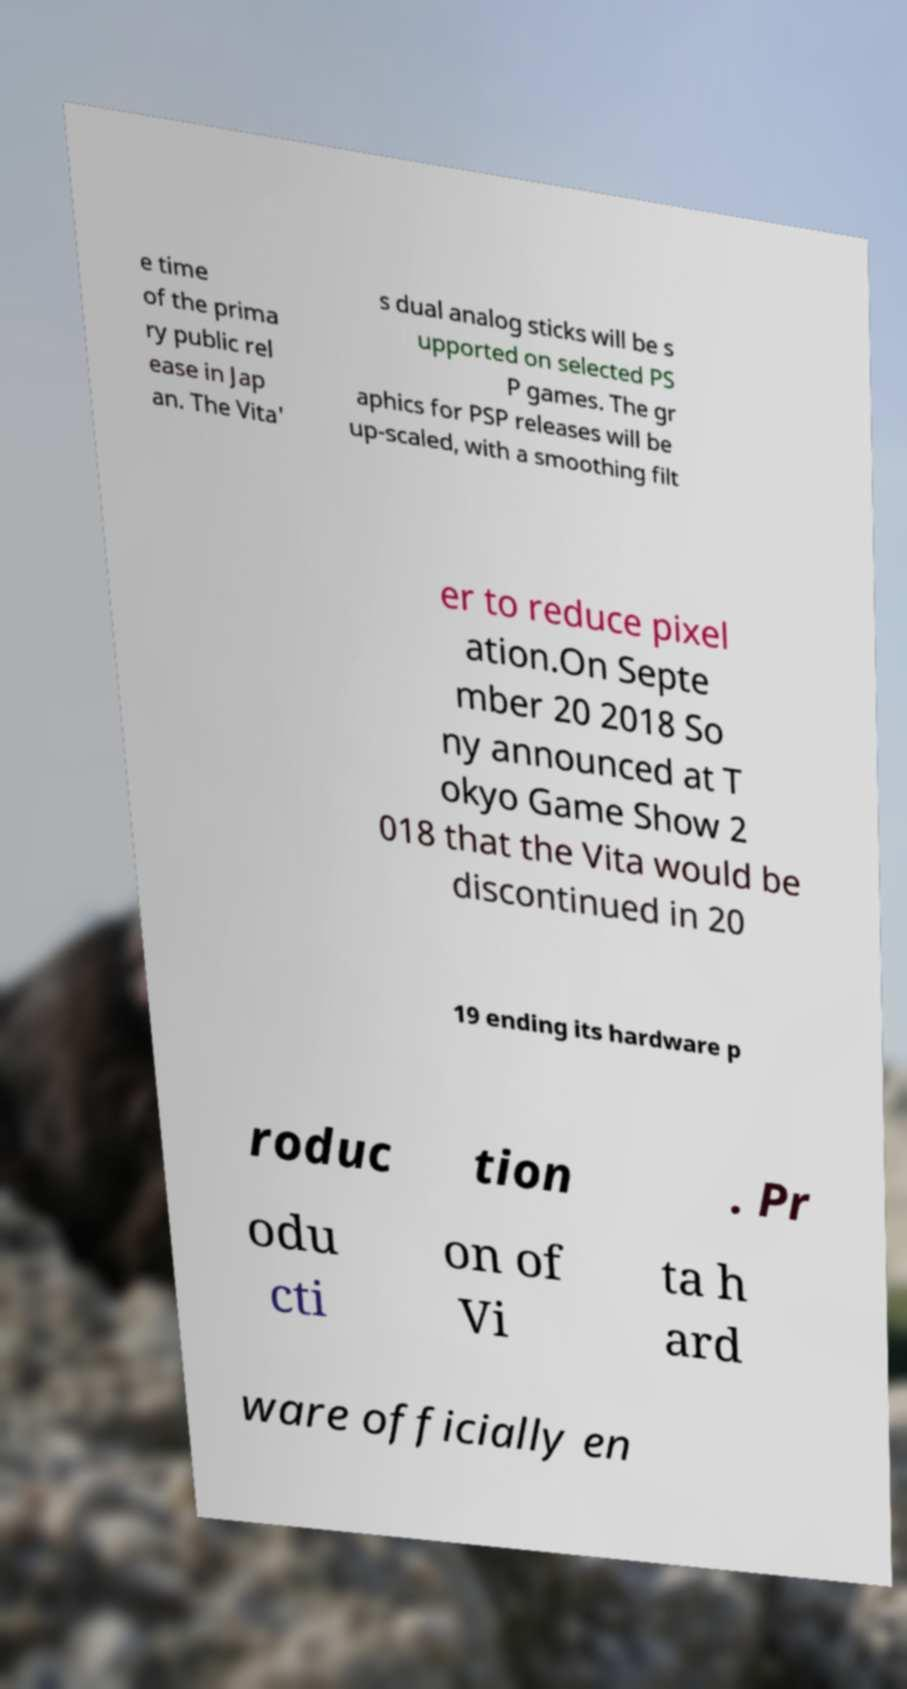Can you accurately transcribe the text from the provided image for me? e time of the prima ry public rel ease in Jap an. The Vita' s dual analog sticks will be s upported on selected PS P games. The gr aphics for PSP releases will be up-scaled, with a smoothing filt er to reduce pixel ation.On Septe mber 20 2018 So ny announced at T okyo Game Show 2 018 that the Vita would be discontinued in 20 19 ending its hardware p roduc tion . Pr odu cti on of Vi ta h ard ware officially en 